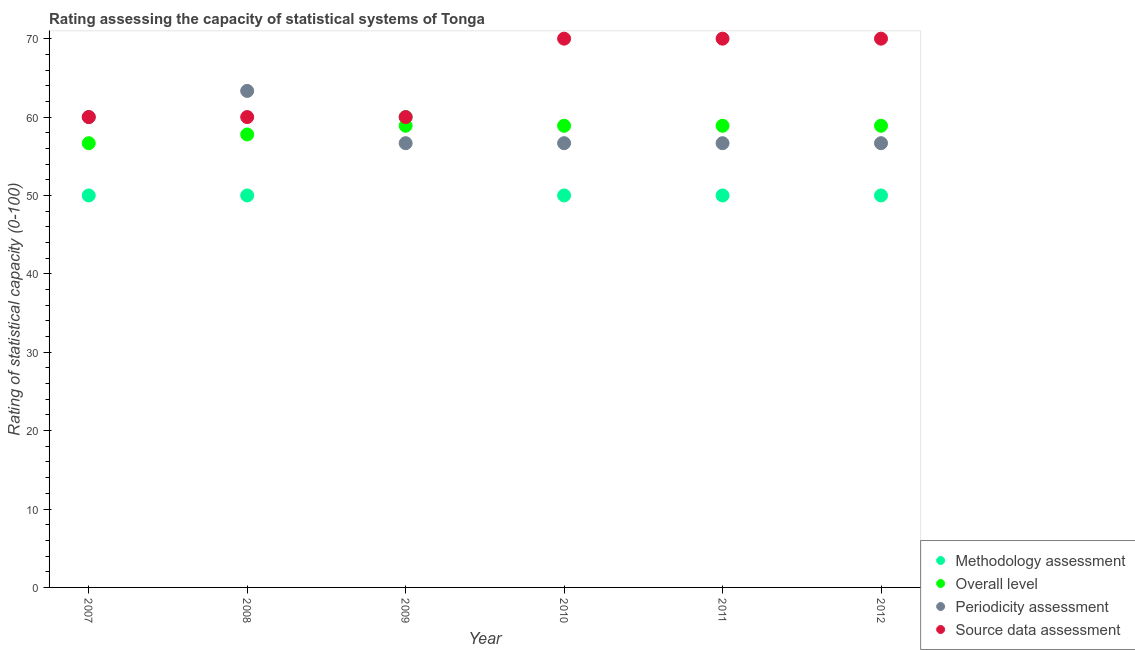Is the number of dotlines equal to the number of legend labels?
Your response must be concise. Yes. What is the source data assessment rating in 2012?
Give a very brief answer. 70. Across all years, what is the maximum periodicity assessment rating?
Your answer should be compact. 63.33. Across all years, what is the minimum overall level rating?
Ensure brevity in your answer.  56.67. What is the total source data assessment rating in the graph?
Offer a terse response. 390. What is the difference between the source data assessment rating in 2008 and that in 2012?
Provide a succinct answer. -10. What is the difference between the overall level rating in 2012 and the source data assessment rating in 2008?
Provide a short and direct response. -1.11. What is the average periodicity assessment rating per year?
Ensure brevity in your answer.  58.33. In the year 2011, what is the difference between the methodology assessment rating and overall level rating?
Provide a short and direct response. -8.89. In how many years, is the periodicity assessment rating greater than 30?
Provide a succinct answer. 6. What is the ratio of the methodology assessment rating in 2009 to that in 2012?
Give a very brief answer. 1.2. Is the difference between the methodology assessment rating in 2009 and 2012 greater than the difference between the periodicity assessment rating in 2009 and 2012?
Your answer should be very brief. Yes. What is the difference between the highest and the lowest overall level rating?
Provide a succinct answer. 2.22. Is it the case that in every year, the sum of the methodology assessment rating and overall level rating is greater than the periodicity assessment rating?
Your answer should be very brief. Yes. Does the methodology assessment rating monotonically increase over the years?
Your response must be concise. No. Is the source data assessment rating strictly greater than the methodology assessment rating over the years?
Ensure brevity in your answer.  No. Is the source data assessment rating strictly less than the overall level rating over the years?
Your response must be concise. No. How many dotlines are there?
Offer a terse response. 4. How many years are there in the graph?
Your answer should be compact. 6. What is the difference between two consecutive major ticks on the Y-axis?
Make the answer very short. 10. What is the title of the graph?
Your response must be concise. Rating assessing the capacity of statistical systems of Tonga. What is the label or title of the X-axis?
Offer a terse response. Year. What is the label or title of the Y-axis?
Your answer should be compact. Rating of statistical capacity (0-100). What is the Rating of statistical capacity (0-100) in Methodology assessment in 2007?
Offer a very short reply. 50. What is the Rating of statistical capacity (0-100) of Overall level in 2007?
Provide a short and direct response. 56.67. What is the Rating of statistical capacity (0-100) of Periodicity assessment in 2007?
Give a very brief answer. 60. What is the Rating of statistical capacity (0-100) in Source data assessment in 2007?
Give a very brief answer. 60. What is the Rating of statistical capacity (0-100) of Methodology assessment in 2008?
Provide a short and direct response. 50. What is the Rating of statistical capacity (0-100) of Overall level in 2008?
Your response must be concise. 57.78. What is the Rating of statistical capacity (0-100) in Periodicity assessment in 2008?
Offer a very short reply. 63.33. What is the Rating of statistical capacity (0-100) in Methodology assessment in 2009?
Your response must be concise. 60. What is the Rating of statistical capacity (0-100) of Overall level in 2009?
Provide a short and direct response. 58.89. What is the Rating of statistical capacity (0-100) of Periodicity assessment in 2009?
Provide a short and direct response. 56.67. What is the Rating of statistical capacity (0-100) of Source data assessment in 2009?
Your answer should be compact. 60. What is the Rating of statistical capacity (0-100) in Overall level in 2010?
Provide a short and direct response. 58.89. What is the Rating of statistical capacity (0-100) in Periodicity assessment in 2010?
Offer a terse response. 56.67. What is the Rating of statistical capacity (0-100) of Source data assessment in 2010?
Ensure brevity in your answer.  70. What is the Rating of statistical capacity (0-100) in Methodology assessment in 2011?
Your answer should be compact. 50. What is the Rating of statistical capacity (0-100) in Overall level in 2011?
Your response must be concise. 58.89. What is the Rating of statistical capacity (0-100) in Periodicity assessment in 2011?
Give a very brief answer. 56.67. What is the Rating of statistical capacity (0-100) of Source data assessment in 2011?
Your answer should be very brief. 70. What is the Rating of statistical capacity (0-100) in Overall level in 2012?
Your response must be concise. 58.89. What is the Rating of statistical capacity (0-100) of Periodicity assessment in 2012?
Your answer should be compact. 56.67. What is the Rating of statistical capacity (0-100) in Source data assessment in 2012?
Keep it short and to the point. 70. Across all years, what is the maximum Rating of statistical capacity (0-100) of Overall level?
Ensure brevity in your answer.  58.89. Across all years, what is the maximum Rating of statistical capacity (0-100) in Periodicity assessment?
Offer a very short reply. 63.33. Across all years, what is the maximum Rating of statistical capacity (0-100) of Source data assessment?
Give a very brief answer. 70. Across all years, what is the minimum Rating of statistical capacity (0-100) of Methodology assessment?
Ensure brevity in your answer.  50. Across all years, what is the minimum Rating of statistical capacity (0-100) of Overall level?
Keep it short and to the point. 56.67. Across all years, what is the minimum Rating of statistical capacity (0-100) in Periodicity assessment?
Provide a succinct answer. 56.67. What is the total Rating of statistical capacity (0-100) in Methodology assessment in the graph?
Make the answer very short. 310. What is the total Rating of statistical capacity (0-100) of Overall level in the graph?
Give a very brief answer. 350. What is the total Rating of statistical capacity (0-100) of Periodicity assessment in the graph?
Keep it short and to the point. 350. What is the total Rating of statistical capacity (0-100) in Source data assessment in the graph?
Your answer should be compact. 390. What is the difference between the Rating of statistical capacity (0-100) in Methodology assessment in 2007 and that in 2008?
Ensure brevity in your answer.  0. What is the difference between the Rating of statistical capacity (0-100) of Overall level in 2007 and that in 2008?
Ensure brevity in your answer.  -1.11. What is the difference between the Rating of statistical capacity (0-100) in Periodicity assessment in 2007 and that in 2008?
Make the answer very short. -3.33. What is the difference between the Rating of statistical capacity (0-100) of Source data assessment in 2007 and that in 2008?
Keep it short and to the point. 0. What is the difference between the Rating of statistical capacity (0-100) of Overall level in 2007 and that in 2009?
Offer a terse response. -2.22. What is the difference between the Rating of statistical capacity (0-100) of Periodicity assessment in 2007 and that in 2009?
Your response must be concise. 3.33. What is the difference between the Rating of statistical capacity (0-100) in Source data assessment in 2007 and that in 2009?
Give a very brief answer. 0. What is the difference between the Rating of statistical capacity (0-100) of Overall level in 2007 and that in 2010?
Your answer should be very brief. -2.22. What is the difference between the Rating of statistical capacity (0-100) of Periodicity assessment in 2007 and that in 2010?
Ensure brevity in your answer.  3.33. What is the difference between the Rating of statistical capacity (0-100) of Source data assessment in 2007 and that in 2010?
Keep it short and to the point. -10. What is the difference between the Rating of statistical capacity (0-100) in Methodology assessment in 2007 and that in 2011?
Keep it short and to the point. 0. What is the difference between the Rating of statistical capacity (0-100) in Overall level in 2007 and that in 2011?
Provide a succinct answer. -2.22. What is the difference between the Rating of statistical capacity (0-100) of Periodicity assessment in 2007 and that in 2011?
Provide a short and direct response. 3.33. What is the difference between the Rating of statistical capacity (0-100) in Overall level in 2007 and that in 2012?
Your answer should be very brief. -2.22. What is the difference between the Rating of statistical capacity (0-100) in Overall level in 2008 and that in 2009?
Make the answer very short. -1.11. What is the difference between the Rating of statistical capacity (0-100) in Periodicity assessment in 2008 and that in 2009?
Ensure brevity in your answer.  6.67. What is the difference between the Rating of statistical capacity (0-100) of Source data assessment in 2008 and that in 2009?
Ensure brevity in your answer.  0. What is the difference between the Rating of statistical capacity (0-100) of Overall level in 2008 and that in 2010?
Make the answer very short. -1.11. What is the difference between the Rating of statistical capacity (0-100) in Source data assessment in 2008 and that in 2010?
Offer a very short reply. -10. What is the difference between the Rating of statistical capacity (0-100) in Methodology assessment in 2008 and that in 2011?
Your response must be concise. 0. What is the difference between the Rating of statistical capacity (0-100) of Overall level in 2008 and that in 2011?
Give a very brief answer. -1.11. What is the difference between the Rating of statistical capacity (0-100) in Periodicity assessment in 2008 and that in 2011?
Give a very brief answer. 6.67. What is the difference between the Rating of statistical capacity (0-100) in Methodology assessment in 2008 and that in 2012?
Provide a short and direct response. 0. What is the difference between the Rating of statistical capacity (0-100) in Overall level in 2008 and that in 2012?
Keep it short and to the point. -1.11. What is the difference between the Rating of statistical capacity (0-100) in Source data assessment in 2008 and that in 2012?
Your answer should be very brief. -10. What is the difference between the Rating of statistical capacity (0-100) in Periodicity assessment in 2009 and that in 2010?
Provide a short and direct response. 0. What is the difference between the Rating of statistical capacity (0-100) of Source data assessment in 2009 and that in 2010?
Provide a succinct answer. -10. What is the difference between the Rating of statistical capacity (0-100) in Periodicity assessment in 2009 and that in 2011?
Give a very brief answer. 0. What is the difference between the Rating of statistical capacity (0-100) in Source data assessment in 2009 and that in 2011?
Keep it short and to the point. -10. What is the difference between the Rating of statistical capacity (0-100) in Methodology assessment in 2009 and that in 2012?
Provide a short and direct response. 10. What is the difference between the Rating of statistical capacity (0-100) of Overall level in 2009 and that in 2012?
Offer a very short reply. 0. What is the difference between the Rating of statistical capacity (0-100) of Periodicity assessment in 2009 and that in 2012?
Your answer should be compact. 0. What is the difference between the Rating of statistical capacity (0-100) in Methodology assessment in 2010 and that in 2011?
Your response must be concise. 0. What is the difference between the Rating of statistical capacity (0-100) in Overall level in 2010 and that in 2011?
Offer a terse response. 0. What is the difference between the Rating of statistical capacity (0-100) in Periodicity assessment in 2010 and that in 2011?
Your response must be concise. 0. What is the difference between the Rating of statistical capacity (0-100) in Source data assessment in 2010 and that in 2011?
Your answer should be very brief. 0. What is the difference between the Rating of statistical capacity (0-100) in Methodology assessment in 2010 and that in 2012?
Ensure brevity in your answer.  0. What is the difference between the Rating of statistical capacity (0-100) in Periodicity assessment in 2010 and that in 2012?
Offer a very short reply. 0. What is the difference between the Rating of statistical capacity (0-100) in Methodology assessment in 2011 and that in 2012?
Provide a succinct answer. 0. What is the difference between the Rating of statistical capacity (0-100) in Overall level in 2011 and that in 2012?
Give a very brief answer. 0. What is the difference between the Rating of statistical capacity (0-100) of Methodology assessment in 2007 and the Rating of statistical capacity (0-100) of Overall level in 2008?
Your answer should be very brief. -7.78. What is the difference between the Rating of statistical capacity (0-100) of Methodology assessment in 2007 and the Rating of statistical capacity (0-100) of Periodicity assessment in 2008?
Offer a very short reply. -13.33. What is the difference between the Rating of statistical capacity (0-100) of Overall level in 2007 and the Rating of statistical capacity (0-100) of Periodicity assessment in 2008?
Ensure brevity in your answer.  -6.67. What is the difference between the Rating of statistical capacity (0-100) in Periodicity assessment in 2007 and the Rating of statistical capacity (0-100) in Source data assessment in 2008?
Offer a very short reply. 0. What is the difference between the Rating of statistical capacity (0-100) of Methodology assessment in 2007 and the Rating of statistical capacity (0-100) of Overall level in 2009?
Offer a terse response. -8.89. What is the difference between the Rating of statistical capacity (0-100) in Methodology assessment in 2007 and the Rating of statistical capacity (0-100) in Periodicity assessment in 2009?
Keep it short and to the point. -6.67. What is the difference between the Rating of statistical capacity (0-100) of Overall level in 2007 and the Rating of statistical capacity (0-100) of Periodicity assessment in 2009?
Offer a very short reply. -0. What is the difference between the Rating of statistical capacity (0-100) in Overall level in 2007 and the Rating of statistical capacity (0-100) in Source data assessment in 2009?
Your answer should be compact. -3.33. What is the difference between the Rating of statistical capacity (0-100) of Periodicity assessment in 2007 and the Rating of statistical capacity (0-100) of Source data assessment in 2009?
Keep it short and to the point. 0. What is the difference between the Rating of statistical capacity (0-100) of Methodology assessment in 2007 and the Rating of statistical capacity (0-100) of Overall level in 2010?
Your answer should be very brief. -8.89. What is the difference between the Rating of statistical capacity (0-100) of Methodology assessment in 2007 and the Rating of statistical capacity (0-100) of Periodicity assessment in 2010?
Give a very brief answer. -6.67. What is the difference between the Rating of statistical capacity (0-100) of Methodology assessment in 2007 and the Rating of statistical capacity (0-100) of Source data assessment in 2010?
Your answer should be compact. -20. What is the difference between the Rating of statistical capacity (0-100) of Overall level in 2007 and the Rating of statistical capacity (0-100) of Periodicity assessment in 2010?
Provide a short and direct response. -0. What is the difference between the Rating of statistical capacity (0-100) in Overall level in 2007 and the Rating of statistical capacity (0-100) in Source data assessment in 2010?
Your response must be concise. -13.33. What is the difference between the Rating of statistical capacity (0-100) in Methodology assessment in 2007 and the Rating of statistical capacity (0-100) in Overall level in 2011?
Your response must be concise. -8.89. What is the difference between the Rating of statistical capacity (0-100) of Methodology assessment in 2007 and the Rating of statistical capacity (0-100) of Periodicity assessment in 2011?
Offer a terse response. -6.67. What is the difference between the Rating of statistical capacity (0-100) in Methodology assessment in 2007 and the Rating of statistical capacity (0-100) in Source data assessment in 2011?
Your answer should be compact. -20. What is the difference between the Rating of statistical capacity (0-100) in Overall level in 2007 and the Rating of statistical capacity (0-100) in Source data assessment in 2011?
Offer a terse response. -13.33. What is the difference between the Rating of statistical capacity (0-100) in Periodicity assessment in 2007 and the Rating of statistical capacity (0-100) in Source data assessment in 2011?
Your answer should be compact. -10. What is the difference between the Rating of statistical capacity (0-100) of Methodology assessment in 2007 and the Rating of statistical capacity (0-100) of Overall level in 2012?
Provide a succinct answer. -8.89. What is the difference between the Rating of statistical capacity (0-100) of Methodology assessment in 2007 and the Rating of statistical capacity (0-100) of Periodicity assessment in 2012?
Provide a short and direct response. -6.67. What is the difference between the Rating of statistical capacity (0-100) of Methodology assessment in 2007 and the Rating of statistical capacity (0-100) of Source data assessment in 2012?
Your response must be concise. -20. What is the difference between the Rating of statistical capacity (0-100) in Overall level in 2007 and the Rating of statistical capacity (0-100) in Periodicity assessment in 2012?
Keep it short and to the point. -0. What is the difference between the Rating of statistical capacity (0-100) in Overall level in 2007 and the Rating of statistical capacity (0-100) in Source data assessment in 2012?
Your answer should be very brief. -13.33. What is the difference between the Rating of statistical capacity (0-100) in Methodology assessment in 2008 and the Rating of statistical capacity (0-100) in Overall level in 2009?
Provide a succinct answer. -8.89. What is the difference between the Rating of statistical capacity (0-100) of Methodology assessment in 2008 and the Rating of statistical capacity (0-100) of Periodicity assessment in 2009?
Your answer should be compact. -6.67. What is the difference between the Rating of statistical capacity (0-100) of Methodology assessment in 2008 and the Rating of statistical capacity (0-100) of Source data assessment in 2009?
Offer a terse response. -10. What is the difference between the Rating of statistical capacity (0-100) in Overall level in 2008 and the Rating of statistical capacity (0-100) in Periodicity assessment in 2009?
Provide a succinct answer. 1.11. What is the difference between the Rating of statistical capacity (0-100) of Overall level in 2008 and the Rating of statistical capacity (0-100) of Source data assessment in 2009?
Provide a succinct answer. -2.22. What is the difference between the Rating of statistical capacity (0-100) of Periodicity assessment in 2008 and the Rating of statistical capacity (0-100) of Source data assessment in 2009?
Ensure brevity in your answer.  3.33. What is the difference between the Rating of statistical capacity (0-100) in Methodology assessment in 2008 and the Rating of statistical capacity (0-100) in Overall level in 2010?
Your response must be concise. -8.89. What is the difference between the Rating of statistical capacity (0-100) in Methodology assessment in 2008 and the Rating of statistical capacity (0-100) in Periodicity assessment in 2010?
Make the answer very short. -6.67. What is the difference between the Rating of statistical capacity (0-100) in Overall level in 2008 and the Rating of statistical capacity (0-100) in Source data assessment in 2010?
Offer a terse response. -12.22. What is the difference between the Rating of statistical capacity (0-100) in Periodicity assessment in 2008 and the Rating of statistical capacity (0-100) in Source data assessment in 2010?
Provide a short and direct response. -6.67. What is the difference between the Rating of statistical capacity (0-100) of Methodology assessment in 2008 and the Rating of statistical capacity (0-100) of Overall level in 2011?
Offer a very short reply. -8.89. What is the difference between the Rating of statistical capacity (0-100) of Methodology assessment in 2008 and the Rating of statistical capacity (0-100) of Periodicity assessment in 2011?
Your answer should be very brief. -6.67. What is the difference between the Rating of statistical capacity (0-100) of Methodology assessment in 2008 and the Rating of statistical capacity (0-100) of Source data assessment in 2011?
Your answer should be compact. -20. What is the difference between the Rating of statistical capacity (0-100) of Overall level in 2008 and the Rating of statistical capacity (0-100) of Source data assessment in 2011?
Your answer should be very brief. -12.22. What is the difference between the Rating of statistical capacity (0-100) in Periodicity assessment in 2008 and the Rating of statistical capacity (0-100) in Source data assessment in 2011?
Provide a succinct answer. -6.67. What is the difference between the Rating of statistical capacity (0-100) in Methodology assessment in 2008 and the Rating of statistical capacity (0-100) in Overall level in 2012?
Make the answer very short. -8.89. What is the difference between the Rating of statistical capacity (0-100) of Methodology assessment in 2008 and the Rating of statistical capacity (0-100) of Periodicity assessment in 2012?
Give a very brief answer. -6.67. What is the difference between the Rating of statistical capacity (0-100) of Overall level in 2008 and the Rating of statistical capacity (0-100) of Source data assessment in 2012?
Offer a terse response. -12.22. What is the difference between the Rating of statistical capacity (0-100) of Periodicity assessment in 2008 and the Rating of statistical capacity (0-100) of Source data assessment in 2012?
Ensure brevity in your answer.  -6.67. What is the difference between the Rating of statistical capacity (0-100) in Overall level in 2009 and the Rating of statistical capacity (0-100) in Periodicity assessment in 2010?
Give a very brief answer. 2.22. What is the difference between the Rating of statistical capacity (0-100) in Overall level in 2009 and the Rating of statistical capacity (0-100) in Source data assessment in 2010?
Your answer should be very brief. -11.11. What is the difference between the Rating of statistical capacity (0-100) of Periodicity assessment in 2009 and the Rating of statistical capacity (0-100) of Source data assessment in 2010?
Make the answer very short. -13.33. What is the difference between the Rating of statistical capacity (0-100) of Methodology assessment in 2009 and the Rating of statistical capacity (0-100) of Periodicity assessment in 2011?
Offer a terse response. 3.33. What is the difference between the Rating of statistical capacity (0-100) of Methodology assessment in 2009 and the Rating of statistical capacity (0-100) of Source data assessment in 2011?
Keep it short and to the point. -10. What is the difference between the Rating of statistical capacity (0-100) of Overall level in 2009 and the Rating of statistical capacity (0-100) of Periodicity assessment in 2011?
Keep it short and to the point. 2.22. What is the difference between the Rating of statistical capacity (0-100) in Overall level in 2009 and the Rating of statistical capacity (0-100) in Source data assessment in 2011?
Give a very brief answer. -11.11. What is the difference between the Rating of statistical capacity (0-100) in Periodicity assessment in 2009 and the Rating of statistical capacity (0-100) in Source data assessment in 2011?
Keep it short and to the point. -13.33. What is the difference between the Rating of statistical capacity (0-100) in Methodology assessment in 2009 and the Rating of statistical capacity (0-100) in Overall level in 2012?
Give a very brief answer. 1.11. What is the difference between the Rating of statistical capacity (0-100) of Methodology assessment in 2009 and the Rating of statistical capacity (0-100) of Periodicity assessment in 2012?
Keep it short and to the point. 3.33. What is the difference between the Rating of statistical capacity (0-100) of Overall level in 2009 and the Rating of statistical capacity (0-100) of Periodicity assessment in 2012?
Your answer should be very brief. 2.22. What is the difference between the Rating of statistical capacity (0-100) of Overall level in 2009 and the Rating of statistical capacity (0-100) of Source data assessment in 2012?
Offer a terse response. -11.11. What is the difference between the Rating of statistical capacity (0-100) of Periodicity assessment in 2009 and the Rating of statistical capacity (0-100) of Source data assessment in 2012?
Provide a succinct answer. -13.33. What is the difference between the Rating of statistical capacity (0-100) of Methodology assessment in 2010 and the Rating of statistical capacity (0-100) of Overall level in 2011?
Provide a short and direct response. -8.89. What is the difference between the Rating of statistical capacity (0-100) in Methodology assessment in 2010 and the Rating of statistical capacity (0-100) in Periodicity assessment in 2011?
Offer a very short reply. -6.67. What is the difference between the Rating of statistical capacity (0-100) in Overall level in 2010 and the Rating of statistical capacity (0-100) in Periodicity assessment in 2011?
Offer a terse response. 2.22. What is the difference between the Rating of statistical capacity (0-100) of Overall level in 2010 and the Rating of statistical capacity (0-100) of Source data assessment in 2011?
Offer a very short reply. -11.11. What is the difference between the Rating of statistical capacity (0-100) of Periodicity assessment in 2010 and the Rating of statistical capacity (0-100) of Source data assessment in 2011?
Offer a very short reply. -13.33. What is the difference between the Rating of statistical capacity (0-100) in Methodology assessment in 2010 and the Rating of statistical capacity (0-100) in Overall level in 2012?
Your answer should be compact. -8.89. What is the difference between the Rating of statistical capacity (0-100) of Methodology assessment in 2010 and the Rating of statistical capacity (0-100) of Periodicity assessment in 2012?
Your response must be concise. -6.67. What is the difference between the Rating of statistical capacity (0-100) of Methodology assessment in 2010 and the Rating of statistical capacity (0-100) of Source data assessment in 2012?
Your answer should be compact. -20. What is the difference between the Rating of statistical capacity (0-100) of Overall level in 2010 and the Rating of statistical capacity (0-100) of Periodicity assessment in 2012?
Provide a short and direct response. 2.22. What is the difference between the Rating of statistical capacity (0-100) in Overall level in 2010 and the Rating of statistical capacity (0-100) in Source data assessment in 2012?
Provide a short and direct response. -11.11. What is the difference between the Rating of statistical capacity (0-100) in Periodicity assessment in 2010 and the Rating of statistical capacity (0-100) in Source data assessment in 2012?
Provide a succinct answer. -13.33. What is the difference between the Rating of statistical capacity (0-100) of Methodology assessment in 2011 and the Rating of statistical capacity (0-100) of Overall level in 2012?
Make the answer very short. -8.89. What is the difference between the Rating of statistical capacity (0-100) in Methodology assessment in 2011 and the Rating of statistical capacity (0-100) in Periodicity assessment in 2012?
Provide a succinct answer. -6.67. What is the difference between the Rating of statistical capacity (0-100) in Methodology assessment in 2011 and the Rating of statistical capacity (0-100) in Source data assessment in 2012?
Ensure brevity in your answer.  -20. What is the difference between the Rating of statistical capacity (0-100) in Overall level in 2011 and the Rating of statistical capacity (0-100) in Periodicity assessment in 2012?
Give a very brief answer. 2.22. What is the difference between the Rating of statistical capacity (0-100) of Overall level in 2011 and the Rating of statistical capacity (0-100) of Source data assessment in 2012?
Provide a succinct answer. -11.11. What is the difference between the Rating of statistical capacity (0-100) in Periodicity assessment in 2011 and the Rating of statistical capacity (0-100) in Source data assessment in 2012?
Make the answer very short. -13.33. What is the average Rating of statistical capacity (0-100) in Methodology assessment per year?
Ensure brevity in your answer.  51.67. What is the average Rating of statistical capacity (0-100) of Overall level per year?
Make the answer very short. 58.33. What is the average Rating of statistical capacity (0-100) of Periodicity assessment per year?
Provide a short and direct response. 58.33. In the year 2007, what is the difference between the Rating of statistical capacity (0-100) of Methodology assessment and Rating of statistical capacity (0-100) of Overall level?
Your response must be concise. -6.67. In the year 2007, what is the difference between the Rating of statistical capacity (0-100) of Methodology assessment and Rating of statistical capacity (0-100) of Periodicity assessment?
Ensure brevity in your answer.  -10. In the year 2008, what is the difference between the Rating of statistical capacity (0-100) of Methodology assessment and Rating of statistical capacity (0-100) of Overall level?
Keep it short and to the point. -7.78. In the year 2008, what is the difference between the Rating of statistical capacity (0-100) of Methodology assessment and Rating of statistical capacity (0-100) of Periodicity assessment?
Ensure brevity in your answer.  -13.33. In the year 2008, what is the difference between the Rating of statistical capacity (0-100) of Methodology assessment and Rating of statistical capacity (0-100) of Source data assessment?
Ensure brevity in your answer.  -10. In the year 2008, what is the difference between the Rating of statistical capacity (0-100) in Overall level and Rating of statistical capacity (0-100) in Periodicity assessment?
Provide a short and direct response. -5.56. In the year 2008, what is the difference between the Rating of statistical capacity (0-100) in Overall level and Rating of statistical capacity (0-100) in Source data assessment?
Ensure brevity in your answer.  -2.22. In the year 2009, what is the difference between the Rating of statistical capacity (0-100) of Methodology assessment and Rating of statistical capacity (0-100) of Overall level?
Provide a succinct answer. 1.11. In the year 2009, what is the difference between the Rating of statistical capacity (0-100) in Methodology assessment and Rating of statistical capacity (0-100) in Periodicity assessment?
Keep it short and to the point. 3.33. In the year 2009, what is the difference between the Rating of statistical capacity (0-100) of Methodology assessment and Rating of statistical capacity (0-100) of Source data assessment?
Ensure brevity in your answer.  0. In the year 2009, what is the difference between the Rating of statistical capacity (0-100) in Overall level and Rating of statistical capacity (0-100) in Periodicity assessment?
Your answer should be very brief. 2.22. In the year 2009, what is the difference between the Rating of statistical capacity (0-100) in Overall level and Rating of statistical capacity (0-100) in Source data assessment?
Provide a short and direct response. -1.11. In the year 2009, what is the difference between the Rating of statistical capacity (0-100) of Periodicity assessment and Rating of statistical capacity (0-100) of Source data assessment?
Offer a terse response. -3.33. In the year 2010, what is the difference between the Rating of statistical capacity (0-100) of Methodology assessment and Rating of statistical capacity (0-100) of Overall level?
Keep it short and to the point. -8.89. In the year 2010, what is the difference between the Rating of statistical capacity (0-100) of Methodology assessment and Rating of statistical capacity (0-100) of Periodicity assessment?
Your response must be concise. -6.67. In the year 2010, what is the difference between the Rating of statistical capacity (0-100) in Methodology assessment and Rating of statistical capacity (0-100) in Source data assessment?
Give a very brief answer. -20. In the year 2010, what is the difference between the Rating of statistical capacity (0-100) of Overall level and Rating of statistical capacity (0-100) of Periodicity assessment?
Make the answer very short. 2.22. In the year 2010, what is the difference between the Rating of statistical capacity (0-100) of Overall level and Rating of statistical capacity (0-100) of Source data assessment?
Ensure brevity in your answer.  -11.11. In the year 2010, what is the difference between the Rating of statistical capacity (0-100) in Periodicity assessment and Rating of statistical capacity (0-100) in Source data assessment?
Offer a very short reply. -13.33. In the year 2011, what is the difference between the Rating of statistical capacity (0-100) in Methodology assessment and Rating of statistical capacity (0-100) in Overall level?
Ensure brevity in your answer.  -8.89. In the year 2011, what is the difference between the Rating of statistical capacity (0-100) of Methodology assessment and Rating of statistical capacity (0-100) of Periodicity assessment?
Keep it short and to the point. -6.67. In the year 2011, what is the difference between the Rating of statistical capacity (0-100) of Methodology assessment and Rating of statistical capacity (0-100) of Source data assessment?
Offer a terse response. -20. In the year 2011, what is the difference between the Rating of statistical capacity (0-100) in Overall level and Rating of statistical capacity (0-100) in Periodicity assessment?
Provide a short and direct response. 2.22. In the year 2011, what is the difference between the Rating of statistical capacity (0-100) in Overall level and Rating of statistical capacity (0-100) in Source data assessment?
Your answer should be very brief. -11.11. In the year 2011, what is the difference between the Rating of statistical capacity (0-100) in Periodicity assessment and Rating of statistical capacity (0-100) in Source data assessment?
Give a very brief answer. -13.33. In the year 2012, what is the difference between the Rating of statistical capacity (0-100) in Methodology assessment and Rating of statistical capacity (0-100) in Overall level?
Your response must be concise. -8.89. In the year 2012, what is the difference between the Rating of statistical capacity (0-100) of Methodology assessment and Rating of statistical capacity (0-100) of Periodicity assessment?
Provide a succinct answer. -6.67. In the year 2012, what is the difference between the Rating of statistical capacity (0-100) of Methodology assessment and Rating of statistical capacity (0-100) of Source data assessment?
Give a very brief answer. -20. In the year 2012, what is the difference between the Rating of statistical capacity (0-100) of Overall level and Rating of statistical capacity (0-100) of Periodicity assessment?
Your answer should be very brief. 2.22. In the year 2012, what is the difference between the Rating of statistical capacity (0-100) in Overall level and Rating of statistical capacity (0-100) in Source data assessment?
Make the answer very short. -11.11. In the year 2012, what is the difference between the Rating of statistical capacity (0-100) of Periodicity assessment and Rating of statistical capacity (0-100) of Source data assessment?
Make the answer very short. -13.33. What is the ratio of the Rating of statistical capacity (0-100) in Methodology assessment in 2007 to that in 2008?
Give a very brief answer. 1. What is the ratio of the Rating of statistical capacity (0-100) in Overall level in 2007 to that in 2008?
Make the answer very short. 0.98. What is the ratio of the Rating of statistical capacity (0-100) of Overall level in 2007 to that in 2009?
Offer a very short reply. 0.96. What is the ratio of the Rating of statistical capacity (0-100) in Periodicity assessment in 2007 to that in 2009?
Your answer should be compact. 1.06. What is the ratio of the Rating of statistical capacity (0-100) in Source data assessment in 2007 to that in 2009?
Ensure brevity in your answer.  1. What is the ratio of the Rating of statistical capacity (0-100) of Overall level in 2007 to that in 2010?
Provide a succinct answer. 0.96. What is the ratio of the Rating of statistical capacity (0-100) of Periodicity assessment in 2007 to that in 2010?
Provide a short and direct response. 1.06. What is the ratio of the Rating of statistical capacity (0-100) of Source data assessment in 2007 to that in 2010?
Your answer should be very brief. 0.86. What is the ratio of the Rating of statistical capacity (0-100) of Methodology assessment in 2007 to that in 2011?
Ensure brevity in your answer.  1. What is the ratio of the Rating of statistical capacity (0-100) of Overall level in 2007 to that in 2011?
Provide a short and direct response. 0.96. What is the ratio of the Rating of statistical capacity (0-100) of Periodicity assessment in 2007 to that in 2011?
Provide a short and direct response. 1.06. What is the ratio of the Rating of statistical capacity (0-100) in Source data assessment in 2007 to that in 2011?
Your answer should be very brief. 0.86. What is the ratio of the Rating of statistical capacity (0-100) in Methodology assessment in 2007 to that in 2012?
Offer a very short reply. 1. What is the ratio of the Rating of statistical capacity (0-100) of Overall level in 2007 to that in 2012?
Provide a succinct answer. 0.96. What is the ratio of the Rating of statistical capacity (0-100) of Periodicity assessment in 2007 to that in 2012?
Your response must be concise. 1.06. What is the ratio of the Rating of statistical capacity (0-100) in Overall level in 2008 to that in 2009?
Make the answer very short. 0.98. What is the ratio of the Rating of statistical capacity (0-100) of Periodicity assessment in 2008 to that in 2009?
Your answer should be compact. 1.12. What is the ratio of the Rating of statistical capacity (0-100) in Methodology assessment in 2008 to that in 2010?
Your response must be concise. 1. What is the ratio of the Rating of statistical capacity (0-100) of Overall level in 2008 to that in 2010?
Your answer should be very brief. 0.98. What is the ratio of the Rating of statistical capacity (0-100) of Periodicity assessment in 2008 to that in 2010?
Your answer should be compact. 1.12. What is the ratio of the Rating of statistical capacity (0-100) in Source data assessment in 2008 to that in 2010?
Provide a short and direct response. 0.86. What is the ratio of the Rating of statistical capacity (0-100) in Overall level in 2008 to that in 2011?
Offer a very short reply. 0.98. What is the ratio of the Rating of statistical capacity (0-100) in Periodicity assessment in 2008 to that in 2011?
Offer a very short reply. 1.12. What is the ratio of the Rating of statistical capacity (0-100) in Overall level in 2008 to that in 2012?
Offer a terse response. 0.98. What is the ratio of the Rating of statistical capacity (0-100) of Periodicity assessment in 2008 to that in 2012?
Provide a succinct answer. 1.12. What is the ratio of the Rating of statistical capacity (0-100) in Methodology assessment in 2009 to that in 2010?
Ensure brevity in your answer.  1.2. What is the ratio of the Rating of statistical capacity (0-100) in Periodicity assessment in 2009 to that in 2010?
Ensure brevity in your answer.  1. What is the ratio of the Rating of statistical capacity (0-100) of Methodology assessment in 2009 to that in 2012?
Offer a very short reply. 1.2. What is the ratio of the Rating of statistical capacity (0-100) of Overall level in 2009 to that in 2012?
Your answer should be compact. 1. What is the ratio of the Rating of statistical capacity (0-100) of Periodicity assessment in 2009 to that in 2012?
Ensure brevity in your answer.  1. What is the ratio of the Rating of statistical capacity (0-100) in Source data assessment in 2009 to that in 2012?
Make the answer very short. 0.86. What is the ratio of the Rating of statistical capacity (0-100) of Methodology assessment in 2010 to that in 2011?
Give a very brief answer. 1. What is the ratio of the Rating of statistical capacity (0-100) of Overall level in 2010 to that in 2011?
Provide a succinct answer. 1. What is the ratio of the Rating of statistical capacity (0-100) of Periodicity assessment in 2010 to that in 2011?
Offer a very short reply. 1. What is the ratio of the Rating of statistical capacity (0-100) of Source data assessment in 2010 to that in 2011?
Provide a short and direct response. 1. What is the ratio of the Rating of statistical capacity (0-100) of Methodology assessment in 2010 to that in 2012?
Your response must be concise. 1. What is the ratio of the Rating of statistical capacity (0-100) in Overall level in 2010 to that in 2012?
Your response must be concise. 1. What is the ratio of the Rating of statistical capacity (0-100) in Periodicity assessment in 2010 to that in 2012?
Your answer should be very brief. 1. What is the ratio of the Rating of statistical capacity (0-100) of Source data assessment in 2010 to that in 2012?
Provide a short and direct response. 1. What is the ratio of the Rating of statistical capacity (0-100) of Overall level in 2011 to that in 2012?
Make the answer very short. 1. What is the ratio of the Rating of statistical capacity (0-100) in Source data assessment in 2011 to that in 2012?
Offer a very short reply. 1. What is the difference between the highest and the second highest Rating of statistical capacity (0-100) of Methodology assessment?
Offer a very short reply. 10. What is the difference between the highest and the second highest Rating of statistical capacity (0-100) in Periodicity assessment?
Give a very brief answer. 3.33. What is the difference between the highest and the lowest Rating of statistical capacity (0-100) in Methodology assessment?
Offer a very short reply. 10. What is the difference between the highest and the lowest Rating of statistical capacity (0-100) in Overall level?
Make the answer very short. 2.22. What is the difference between the highest and the lowest Rating of statistical capacity (0-100) of Source data assessment?
Keep it short and to the point. 10. 